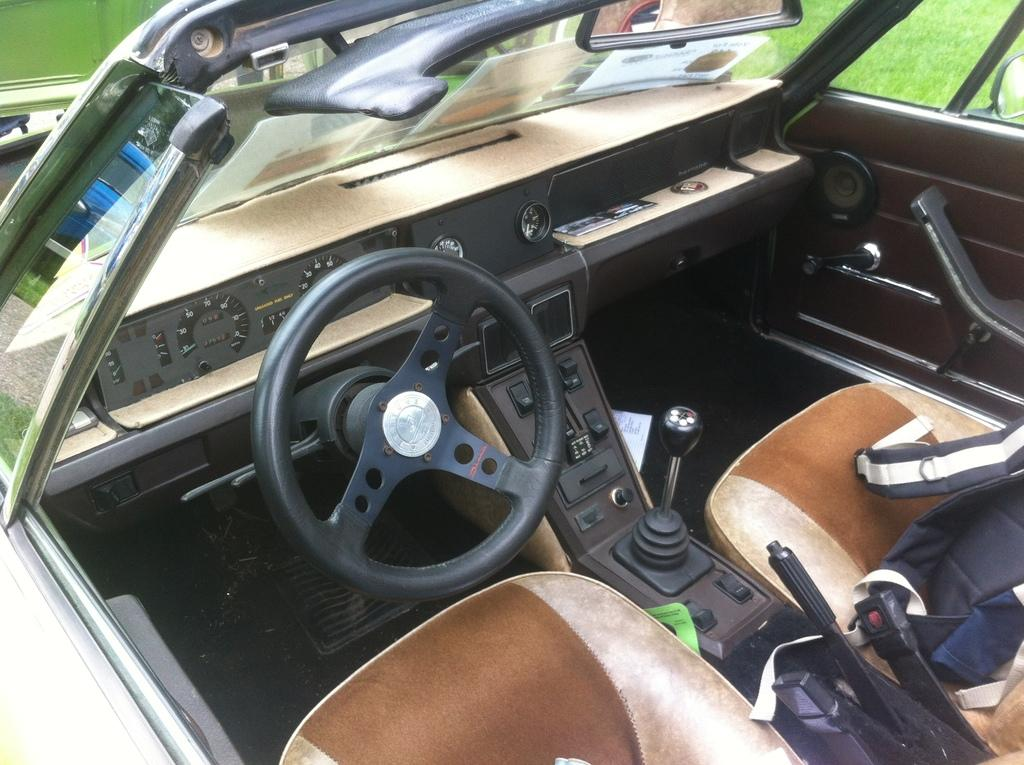What type of space is depicted in the image? The image shows the interior of a vehicle. What is the primary control mechanism in the vehicle? There is a steering wheel in the image. What are the seats used for in the vehicle? The seats are for passengers to sit in while inside the vehicle. What is used for observing the rear of the vehicle? A mirror is visible in the image. How do passengers enter or exit the vehicle? A car door is present in the image. What is the texture of the top of the vehicle in the image? The image does not show the top of the vehicle, so it is not possible to determine its texture. 